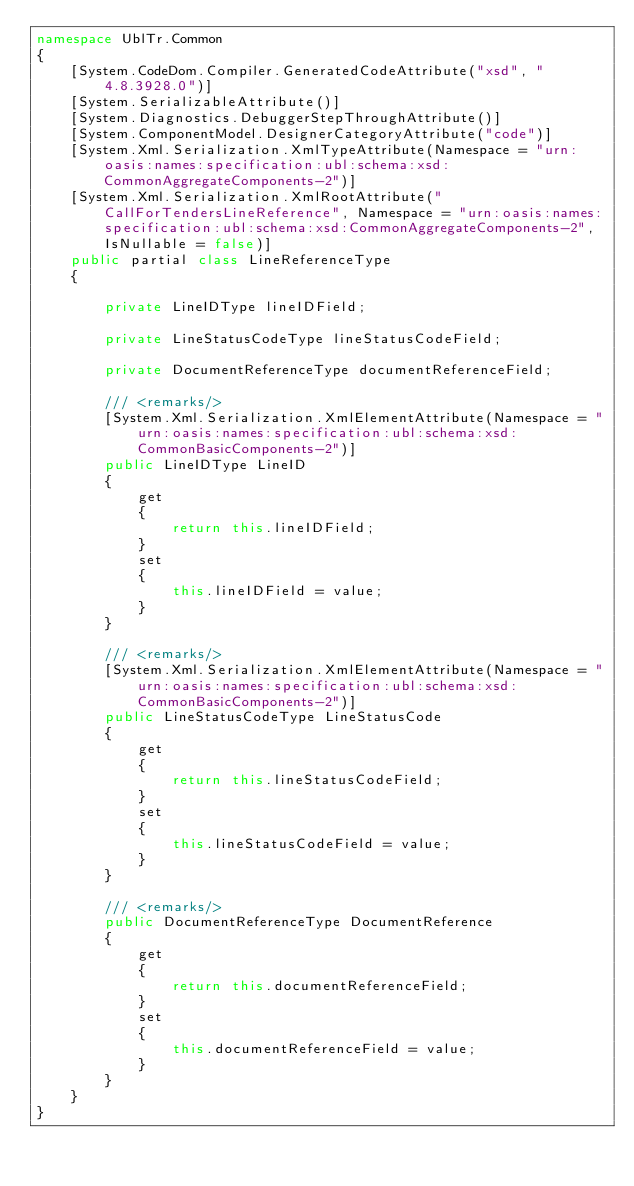Convert code to text. <code><loc_0><loc_0><loc_500><loc_500><_C#_>namespace UblTr.Common
{
    [System.CodeDom.Compiler.GeneratedCodeAttribute("xsd", "4.8.3928.0")]
    [System.SerializableAttribute()]
    [System.Diagnostics.DebuggerStepThroughAttribute()]
    [System.ComponentModel.DesignerCategoryAttribute("code")]
    [System.Xml.Serialization.XmlTypeAttribute(Namespace = "urn:oasis:names:specification:ubl:schema:xsd:CommonAggregateComponents-2")]
    [System.Xml.Serialization.XmlRootAttribute("CallForTendersLineReference", Namespace = "urn:oasis:names:specification:ubl:schema:xsd:CommonAggregateComponents-2", IsNullable = false)]
    public partial class LineReferenceType
    {

        private LineIDType lineIDField;

        private LineStatusCodeType lineStatusCodeField;

        private DocumentReferenceType documentReferenceField;

        /// <remarks/>
        [System.Xml.Serialization.XmlElementAttribute(Namespace = "urn:oasis:names:specification:ubl:schema:xsd:CommonBasicComponents-2")]
        public LineIDType LineID
        {
            get
            {
                return this.lineIDField;
            }
            set
            {
                this.lineIDField = value;
            }
        }

        /// <remarks/>
        [System.Xml.Serialization.XmlElementAttribute(Namespace = "urn:oasis:names:specification:ubl:schema:xsd:CommonBasicComponents-2")]
        public LineStatusCodeType LineStatusCode
        {
            get
            {
                return this.lineStatusCodeField;
            }
            set
            {
                this.lineStatusCodeField = value;
            }
        }

        /// <remarks/>
        public DocumentReferenceType DocumentReference
        {
            get
            {
                return this.documentReferenceField;
            }
            set
            {
                this.documentReferenceField = value;
            }
        }
    }
}</code> 